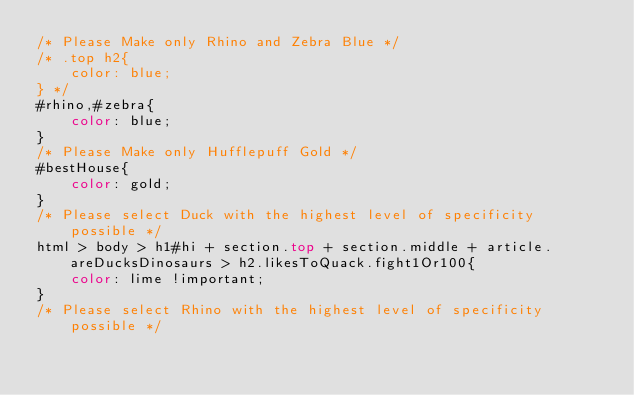<code> <loc_0><loc_0><loc_500><loc_500><_CSS_>/* Please Make only Rhino and Zebra Blue */
/* .top h2{
    color: blue;
} */
#rhino,#zebra{
    color: blue;
}
/* Please Make only Hufflepuff Gold */
#bestHouse{
    color: gold;
}
/* Please select Duck with the highest level of specificity possible */
html > body > h1#hi + section.top + section.middle + article.areDucksDinosaurs > h2.likesToQuack.fight1Or100{
    color: lime !important;
}
/* Please select Rhino with the highest level of specificity possible */
</code> 